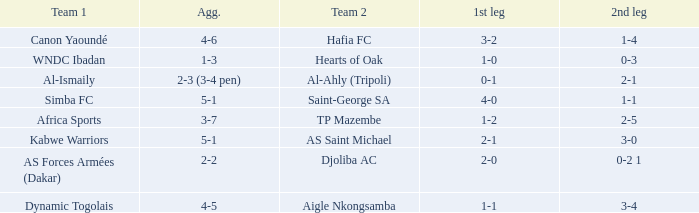What team played against Hafia FC (team 2)? Canon Yaoundé. 